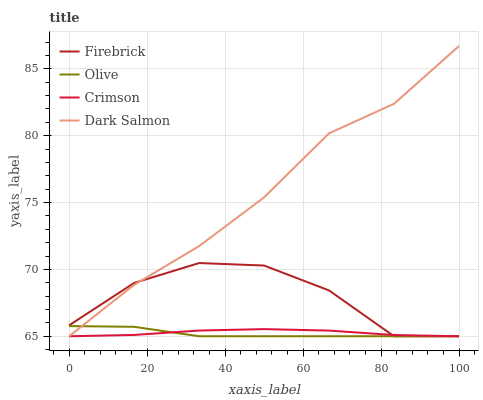Does Olive have the minimum area under the curve?
Answer yes or no. Yes. Does Dark Salmon have the maximum area under the curve?
Answer yes or no. Yes. Does Crimson have the minimum area under the curve?
Answer yes or no. No. Does Crimson have the maximum area under the curve?
Answer yes or no. No. Is Crimson the smoothest?
Answer yes or no. Yes. Is Firebrick the roughest?
Answer yes or no. Yes. Is Firebrick the smoothest?
Answer yes or no. No. Is Crimson the roughest?
Answer yes or no. No. Does Dark Salmon have the highest value?
Answer yes or no. Yes. Does Firebrick have the highest value?
Answer yes or no. No. Does Firebrick intersect Dark Salmon?
Answer yes or no. Yes. Is Firebrick less than Dark Salmon?
Answer yes or no. No. Is Firebrick greater than Dark Salmon?
Answer yes or no. No. 